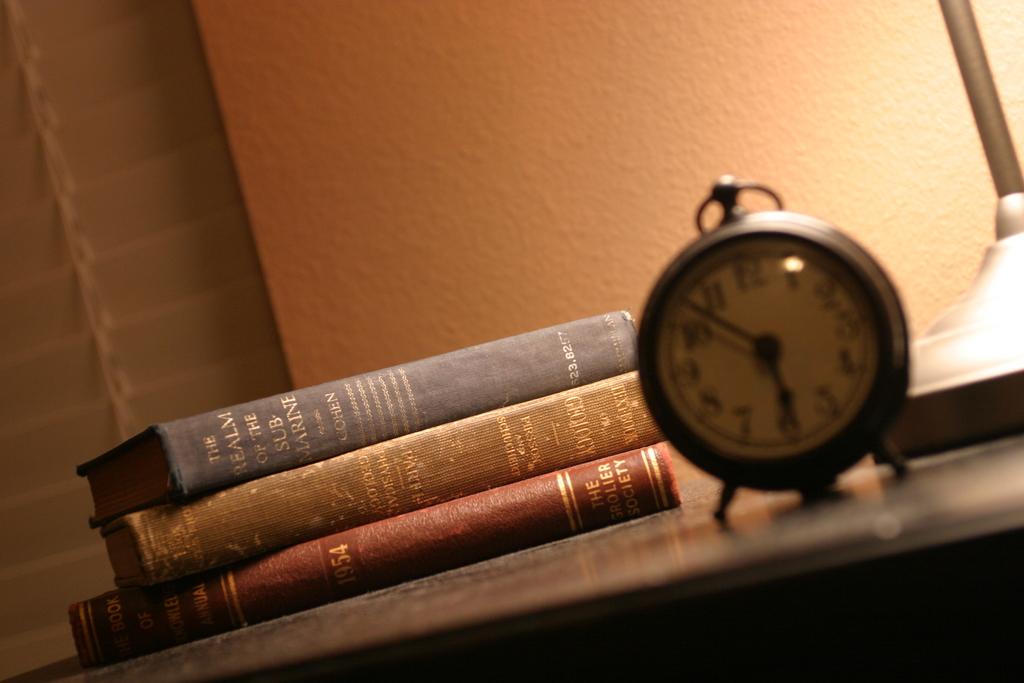What is the title of the book on the top of the stack?
Offer a very short reply. The realm of the submarine. What year was the red book written?
Offer a very short reply. 1954. 